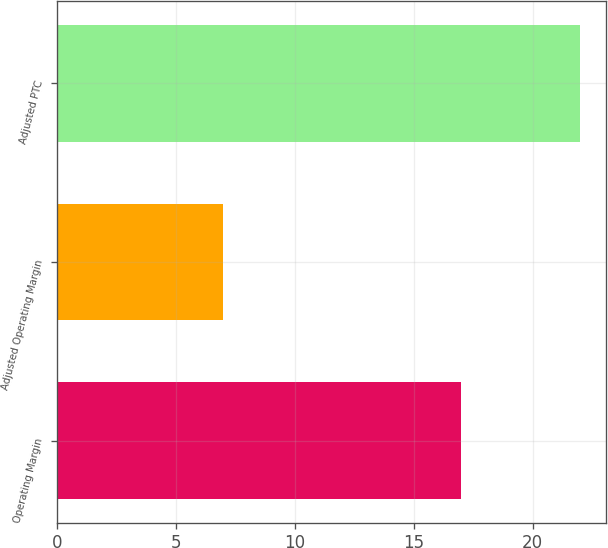<chart> <loc_0><loc_0><loc_500><loc_500><bar_chart><fcel>Operating Margin<fcel>Adjusted Operating Margin<fcel>Adjusted PTC<nl><fcel>17<fcel>7<fcel>22<nl></chart> 